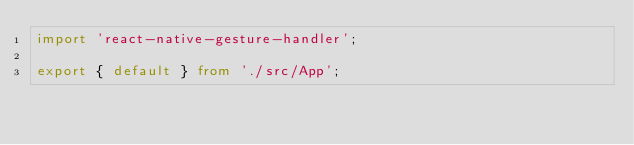Convert code to text. <code><loc_0><loc_0><loc_500><loc_500><_TypeScript_>import 'react-native-gesture-handler';

export { default } from './src/App';
</code> 